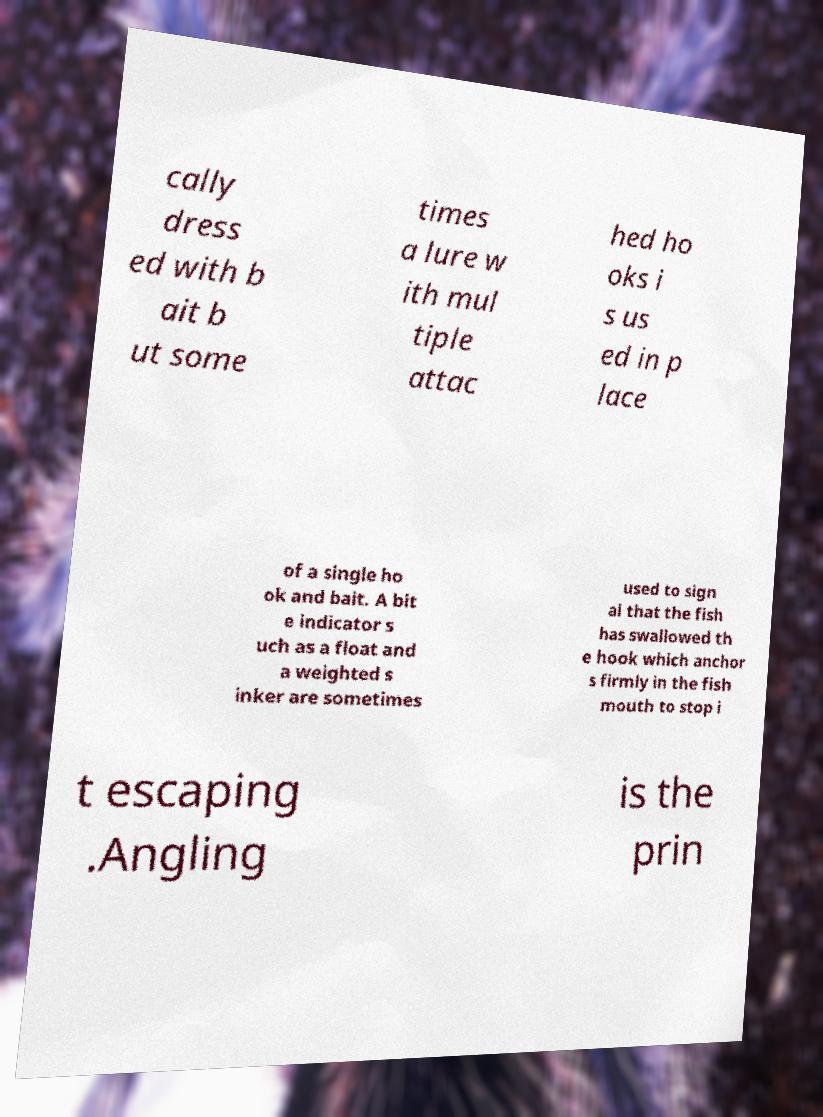I need the written content from this picture converted into text. Can you do that? cally dress ed with b ait b ut some times a lure w ith mul tiple attac hed ho oks i s us ed in p lace of a single ho ok and bait. A bit e indicator s uch as a float and a weighted s inker are sometimes used to sign al that the fish has swallowed th e hook which anchor s firmly in the fish mouth to stop i t escaping .Angling is the prin 